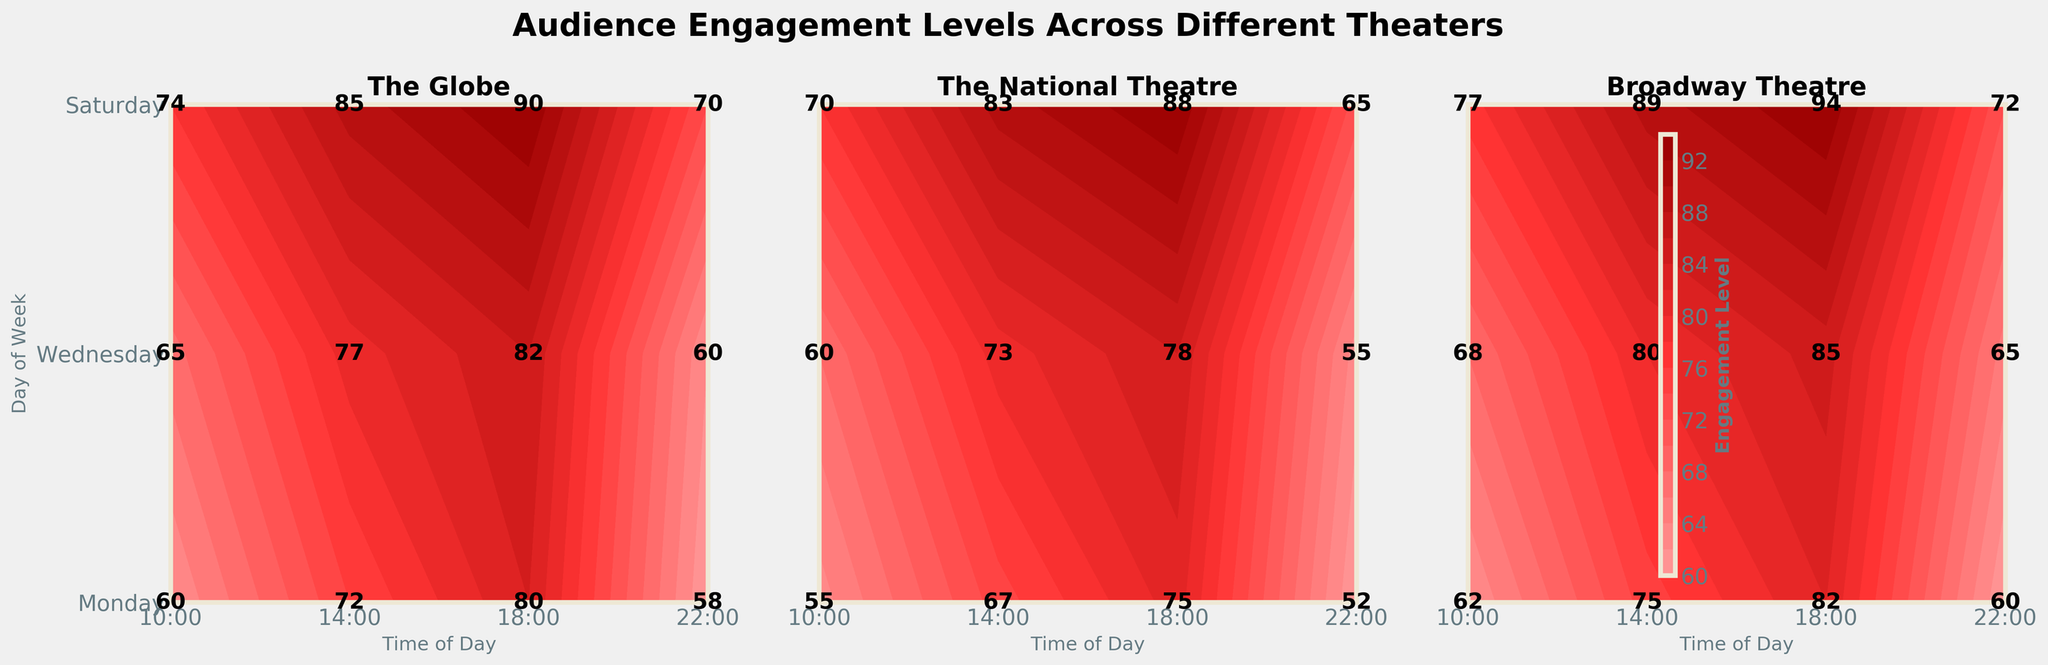What is the title of the plot? The title of the plot is positioned above the figure and provides an overall description of what the plot represents. It is written in bold font.
Answer: Audience Engagement Levels Across Different Theaters Which theater shows the highest engagement level on Saturdays at 18:00? To find the highest engagement level, look at the contour plots for each theater, focusing on the cell corresponding to Saturday and 18:00. Note the engagement levels labeled within the cell.
Answer: Broadway Theatre On which day and at what time does The Globe have a lowest engagement level? Find the contour plot for The Globe and identify the cell with the lowest numerical label. Read the day and time this cell corresponds to.
Answer: Monday at 22:00 What is the average engagement level at 14:00 for all theaters on Wednesdays? Find the engagement level for each theater at 14:00 on Wednesday, sum these values, and divide by the number of theaters. These engagement levels are 77 (The Globe), 73 (The National Theatre), and 80 (Broadway Theatre). Calculate the average: (77+73+80)/3 = 230/3.
Answer: 76.67 Which theater shows the greater increase in engagement level from 10:00 to 18:00 on Saturdays? Calculate the difference in engagement level from 10:00 to 18:00 on Saturday for each theater: (18:00 - 10:00). Compare these differences for each theater. The Globe: 90-74, The National Theatre: 88-70, Broadway Theatre: 94-77.
Answer: Broadway Theatre How does the engagement level at 22:00 on Mondays compare across the three theaters? Look at the engagement level labeled in the cells corresponding to 22:00 on Mondays for each theater and compare them. The values are 58 (The Globe), 52 (The National Theatre), and 60 (Broadway Theatre).
Answer: Broadway Theatre > The Globe > The National Theatre Which day generally shows higher engagement levels at The National Theatre, Wednesday or Saturday? Compare the labeled engagement levels for The National Theatre on Wednesday and Saturday at different times (10:00, 14:00, 18:00, 22:00). Sum the engagement levels for each day and compare. Wednesday: 60+73+78+55 = 266, Saturday: 70+83+88+65 = 306.
Answer: Saturday How do engagement levels at 10:00 on Mondays compare across all theaters? Identify the engagement levels at 10:00 on Mondays for each theater and compare: The Globe (60), The National Theatre (55), and Broadway Theatre (62).
Answer: Broadway Theatre > The Globe > The National Theatre What is the engagement level at The Globe on Wednesdays at 14:00? Locate the contour plot for The Globe and find the value labeled in the cell for Wednesday at 14:00.
Answer: 77 